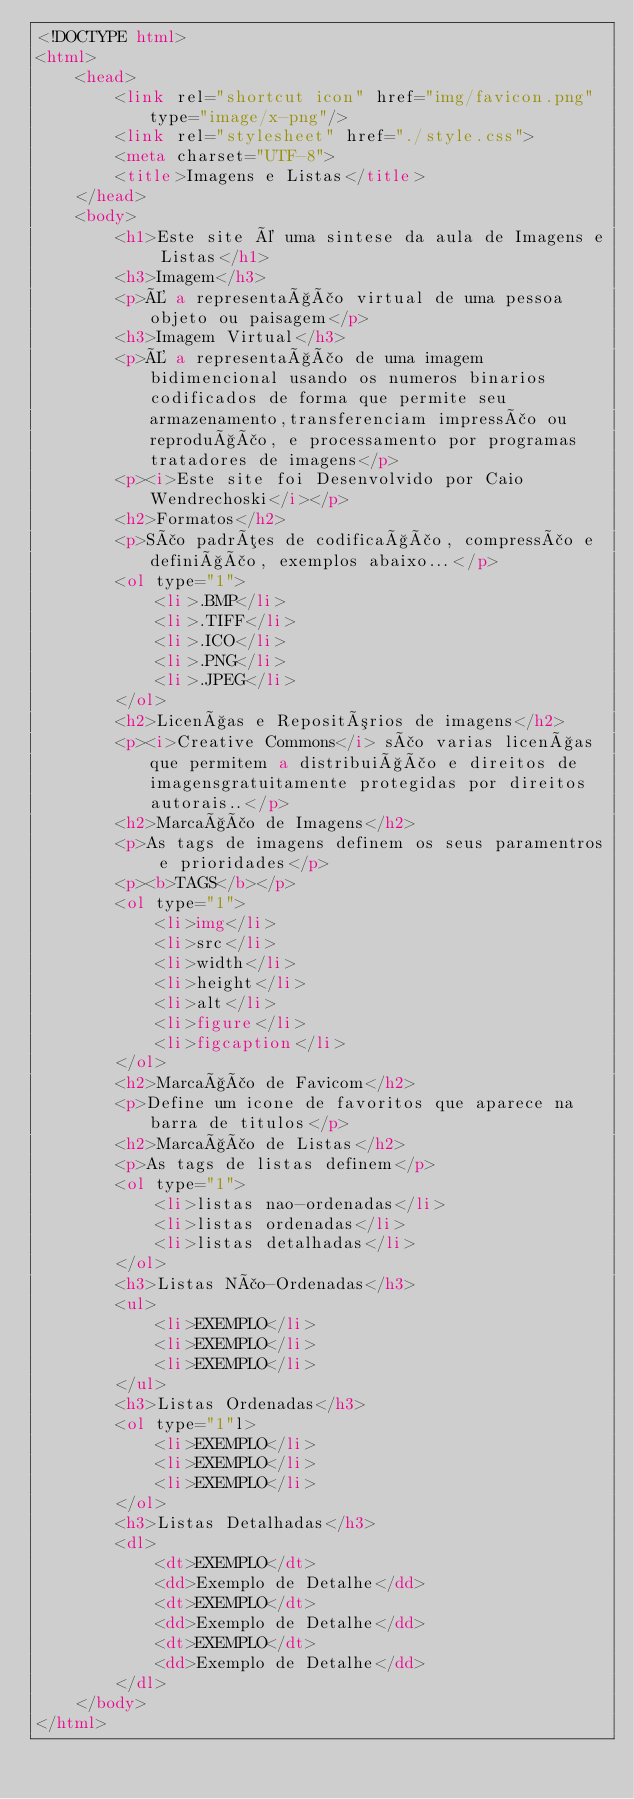<code> <loc_0><loc_0><loc_500><loc_500><_HTML_><!DOCTYPE html>
<html>
    <head>
        <link rel="shortcut icon" href="img/favicon.png" type="image/x-png"/>
        <link rel="stylesheet" href="./style.css">
        <meta charset="UTF-8">
        <title>Imagens e Listas</title>
    </head>
    <body>
        <h1>Este site é uma sintese da aula de Imagens e Listas</h1>
        <h3>Imagem</h3>
        <p>É a representação virtual de uma pessoa objeto ou paisagem</p>
        <h3>Imagem Virtual</h3>
        <p>É a representação de uma imagem bidimencional usando os numeros binarios codificados de forma que permite seu armazenamento,transferenciam impressão ou reprodução, e processamento por programas tratadores de imagens</p>
        <p><i>Este site foi Desenvolvido por Caio Wendrechoski</i></p>
        <h2>Formatos</h2>
        <p>São padrões de codificação, compressão e definição, exemplos abaixo...</p>
        <ol type="1"> 
            <li>.BMP</li>
            <li>.TIFF</li>
            <li>.ICO</li>
            <li>.PNG</li>
            <li>.JPEG</li>
        </ol>
        <h2>Licenças e Repositórios de imagens</h2>
        <p><i>Creative Commons</i> são varias licenças que permitem a distribuição e direitos de imagensgratuitamente protegidas por direitos autorais..</p>
        <h2>Marcação de Imagens</h2>
        <p>As tags de imagens definem os seus paramentros e prioridades</p>
        <p><b>TAGS</b></p>
        <ol type="1"> 
            <li>img</li>
            <li>src</li>
            <li>width</li>
            <li>height</li>
            <li>alt</li>
            <li>figure</li>
            <li>figcaption</li>
        </ol>
        <h2>Marcação de Favicom</h2>
        <p>Define um icone de favoritos que aparece na barra de titulos</p>
        <h2>Marcação de Listas</h2>
        <p>As tags de listas definem</p>
        <ol type="1"> 
            <li>listas nao-ordenadas</li>
            <li>listas ordenadas</li>
            <li>listas detalhadas</li>
        </ol>
        <h3>Listas Não-Ordenadas</h3>
        <ul>
            <li>EXEMPLO</li>
            <li>EXEMPLO</li>
            <li>EXEMPLO</li>
        </ul>
        <h3>Listas Ordenadas</h3>
        <ol type="1"l>
            <li>EXEMPLO</li>
            <li>EXEMPLO</li>
            <li>EXEMPLO</li>
        </ol>
        <h3>Listas Detalhadas</h3>
        <dl>
            <dt>EXEMPLO</dt>
            <dd>Exemplo de Detalhe</dd>
            <dt>EXEMPLO</dt>
            <dd>Exemplo de Detalhe</dd>
            <dt>EXEMPLO</dt>
            <dd>Exemplo de Detalhe</dd>
        </dl>
    </body>
</html></code> 